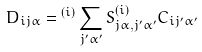<formula> <loc_0><loc_0><loc_500><loc_500>D _ { i j \alpha } = { ^ { ( i ) } } \sum _ { j ^ { \prime } \alpha ^ { \prime } } S ^ { ( i ) } _ { j \alpha , j ^ { \prime } \alpha ^ { \prime } } C _ { i j ^ { \prime } \alpha ^ { \prime } }</formula> 